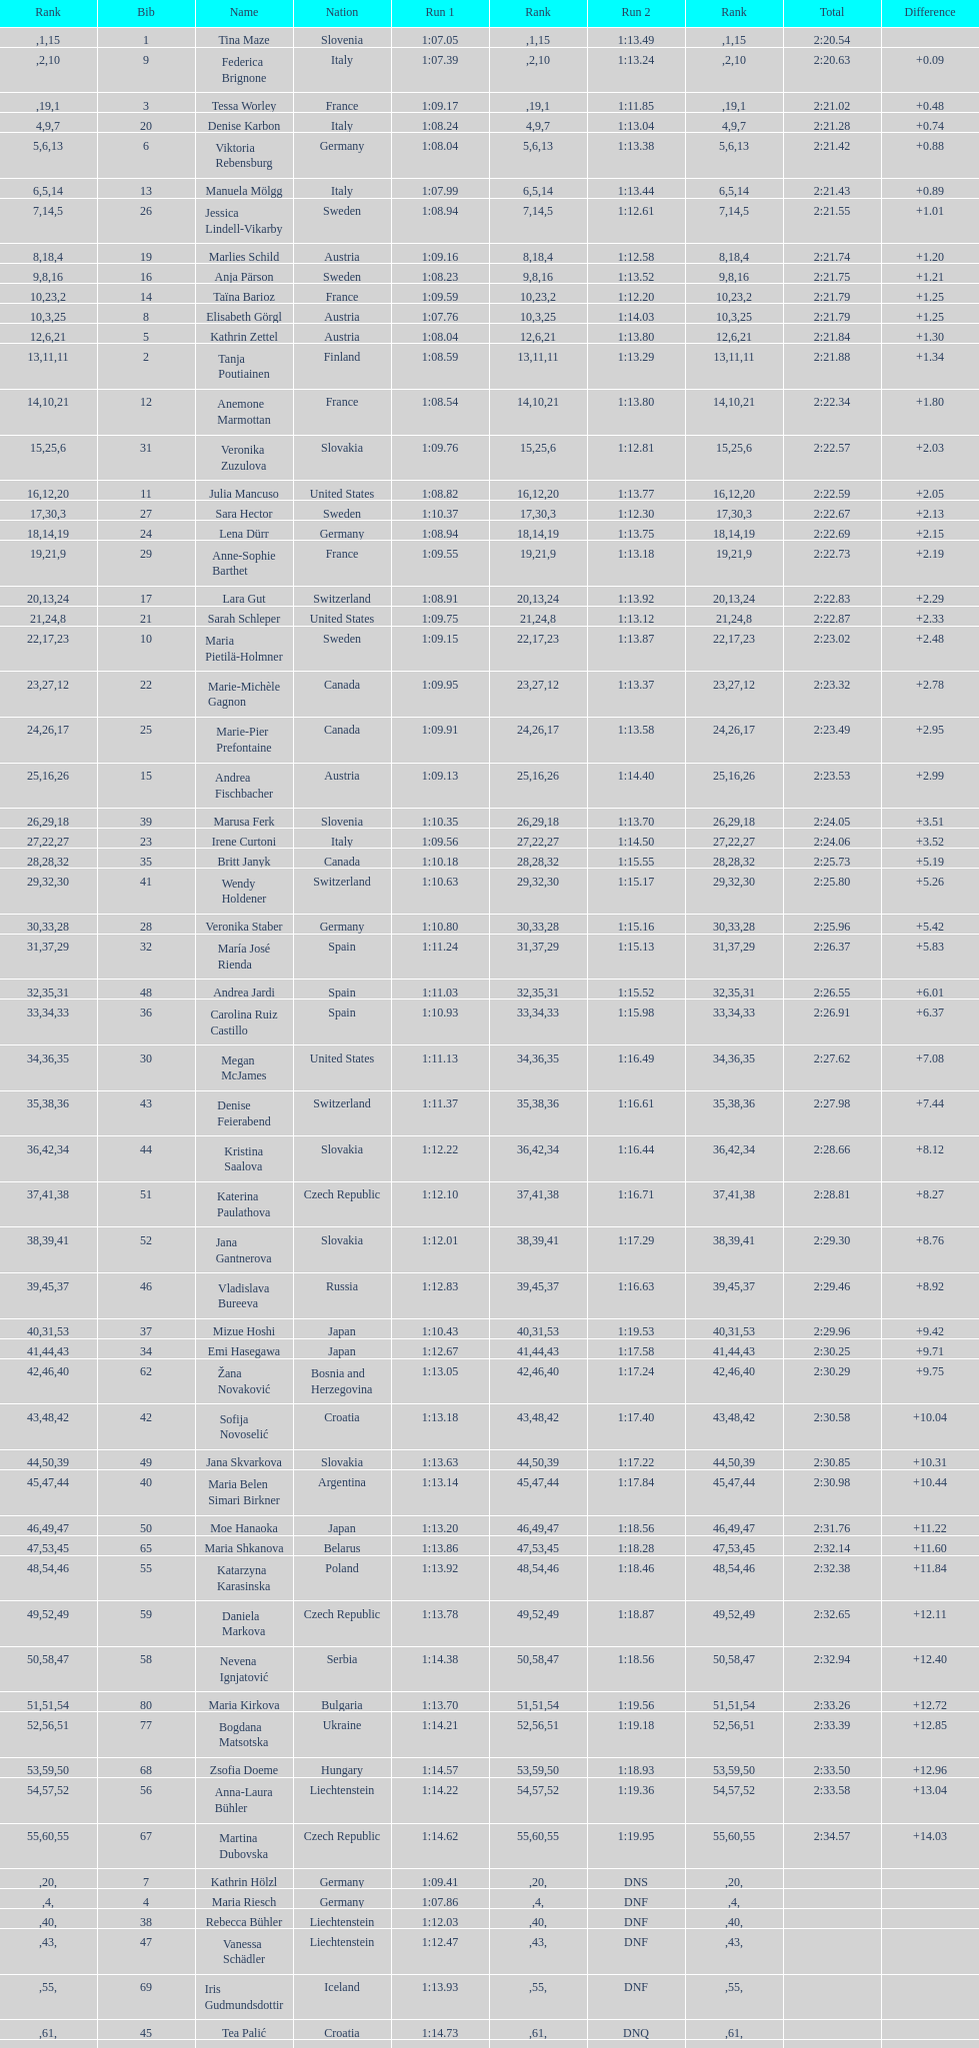Who finished next after federica brignone? Tessa Worley. 